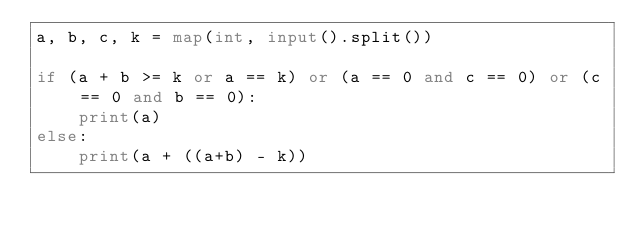Convert code to text. <code><loc_0><loc_0><loc_500><loc_500><_Python_>a, b, c, k = map(int, input().split())

if (a + b >= k or a == k) or (a == 0 and c == 0) or (c == 0 and b == 0):
    print(a)
else:
    print(a + ((a+b) - k))
</code> 